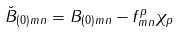<formula> <loc_0><loc_0><loc_500><loc_500>\breve { B } _ { ( 0 ) m n } = B _ { ( 0 ) m n } - f ^ { p } _ { m n } \chi _ { p }</formula> 